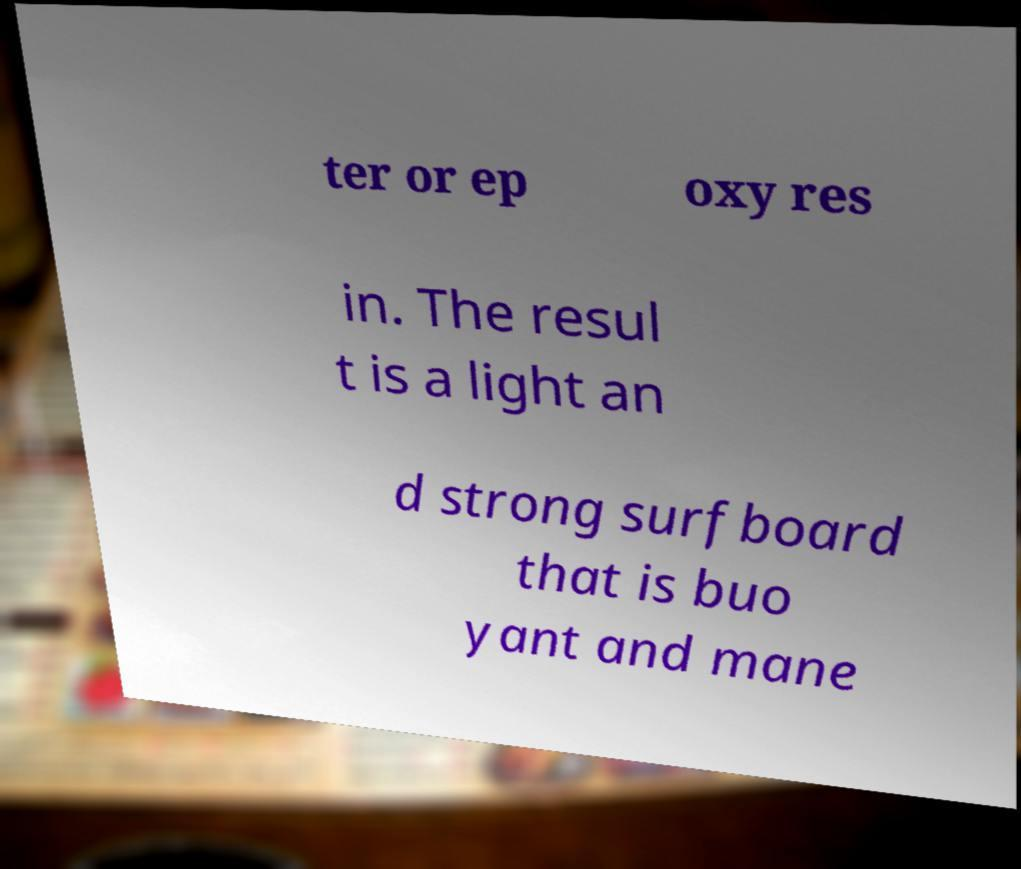There's text embedded in this image that I need extracted. Can you transcribe it verbatim? ter or ep oxy res in. The resul t is a light an d strong surfboard that is buo yant and mane 